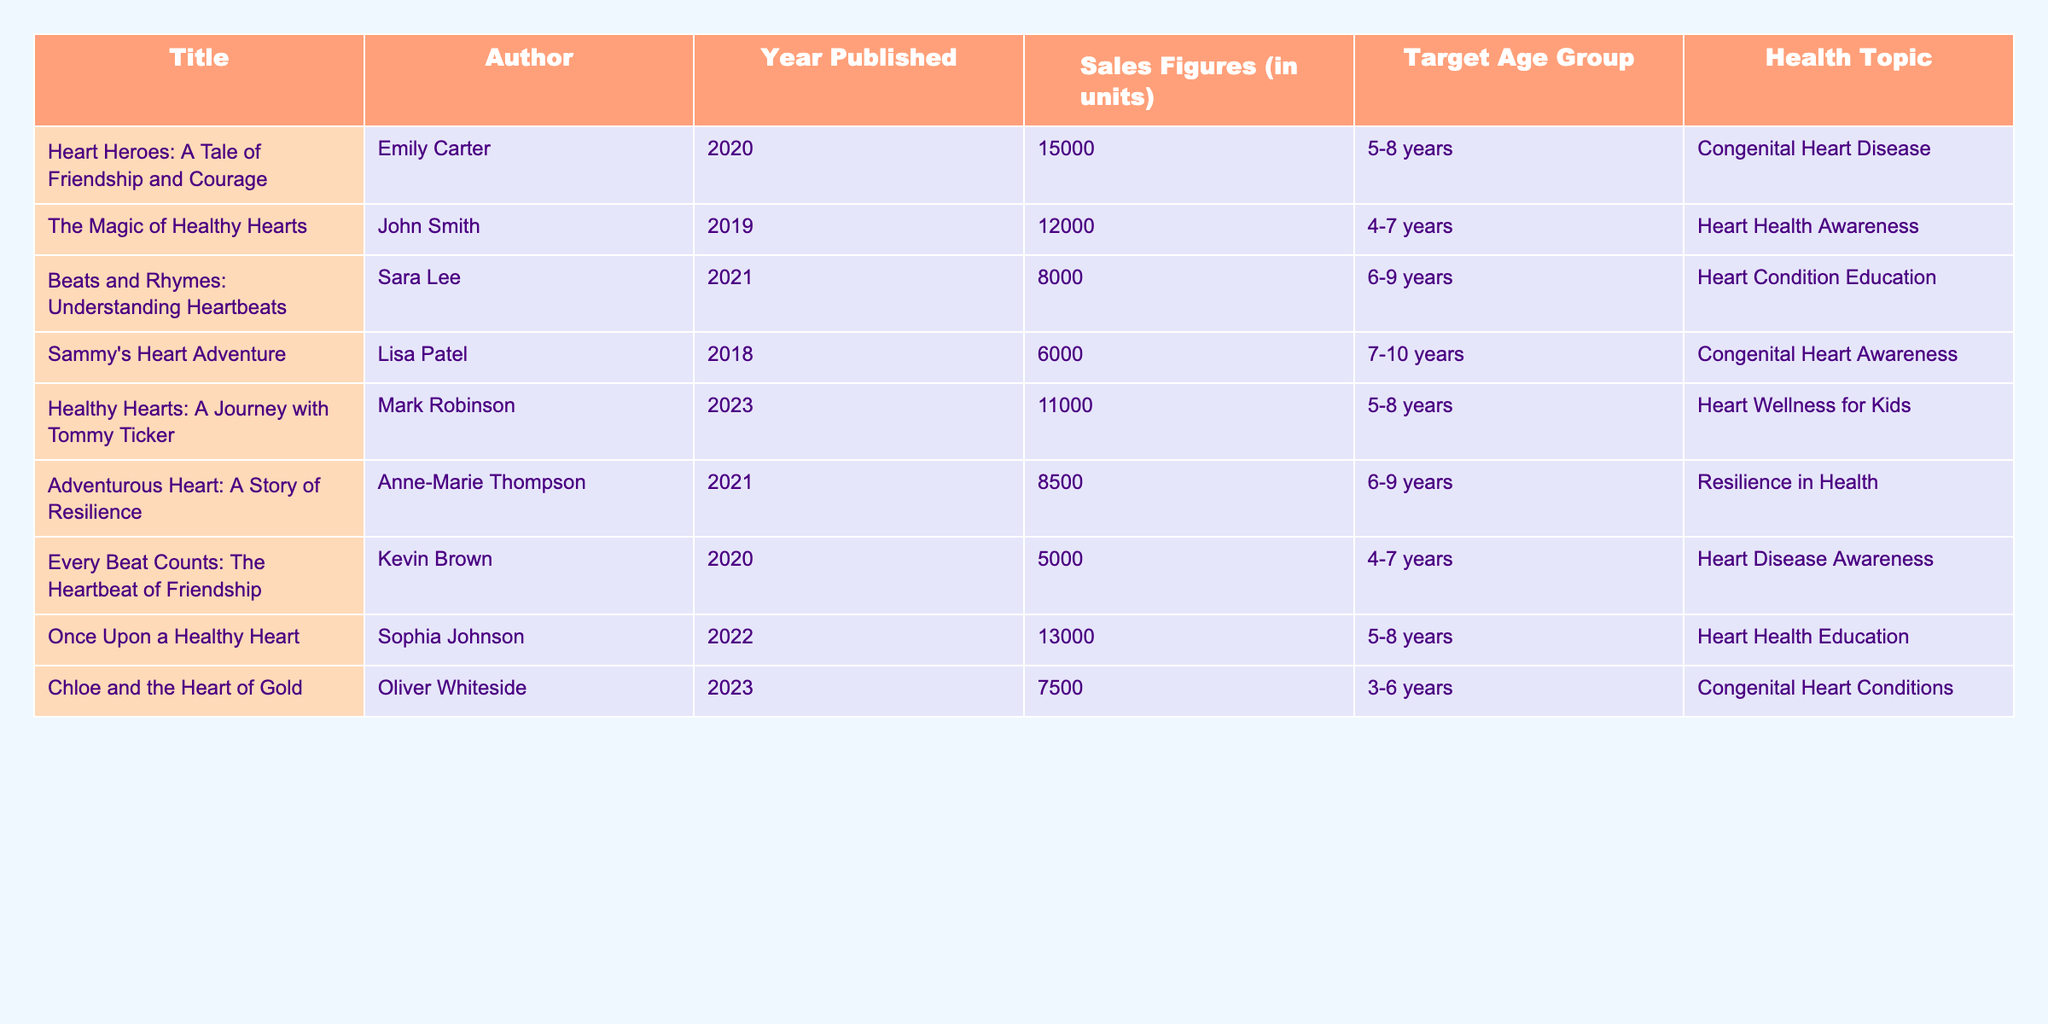What is the title of the book with the highest sales figures? By examining the "Sales Figures" column, "Heart Heroes: A Tale of Friendship and Courage" has the highest sales of 15,000 units.
Answer: Heart Heroes: A Tale of Friendship and Courage Which author wrote a book about resilience in health? "Adventurous Heart: A Story of Resilience" is the book about resilience in health, and it was written by Anne-Marie Thompson.
Answer: Anne-Marie Thompson How many books are listed that specifically address congenital heart conditions? The books about congenital heart conditions are "Heart Heroes: A Tale of Friendship and Courage," "Sammy's Heart Adventure," and "Chloe and the Heart of Gold," totaling three books.
Answer: 3 What is the average sales figure for books targeting the age group 5-8 years? The sales figures for 5-8 years age group are 15,000, 11,000, and 13,000. The average is calculated as (15,000 + 11,000 + 13,000) / 3 = 13,000.
Answer: 13,000 Is there a book published in 2023 addressing heart wellness for kids? Yes, "Healthy Hearts: A Journey with Tommy Ticker" was published in 2023 and addresses heart wellness for kids.
Answer: Yes Which health topic has the lowest sales figure, and what is that figure? By comparing the sales figures, "Every Beat Counts: The Heartbeat of Friendship" has the lowest sales at 5,000 units, relating to heart disease awareness.
Answer: 5,000 What is the total number of units sold for books related to heart health awareness? The total sales figures for heart health awareness are summed as 12,000 (The Magic of Healthy Hearts) + 5,000 (Every Beat Counts) + 13,000 (Once Upon a Healthy Heart) = 30,000 units.
Answer: 30,000 How many authors have published books about congenital heart disease? The authors of books related to congenital heart disease are Emily Carter, Lisa Patel, and Oliver Whiteside, so three authors have published such books.
Answer: 3 Which book has the second highest sales figure, and what are its sales figures? The second highest sales figure is "Once Upon a Healthy Heart" with sales figures of 13,000 units.
Answer: Once Upon a Healthy Heart, 13,000 What percentage of total sales do the books published in 2021 contribute to? The total sales figures for 2021 are 8,000 (Beats and Rhymes) + 8,500 (Adventurous Heart) = 16,500. The overall total sales are 15,000 + 12,000 + 8,000 + 6,000 + 11,000 + 8,500 + 5,000 + 13,000 + 7,500 =  83,000. The percentage is (16,500 / 83,000) * 100 ≈ 19.88%.
Answer: Approximately 19.88% 